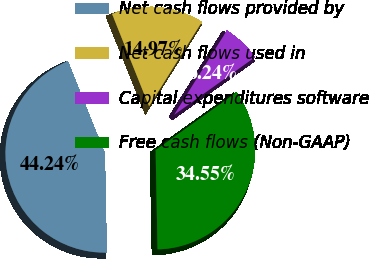Convert chart to OTSL. <chart><loc_0><loc_0><loc_500><loc_500><pie_chart><fcel>Net cash flows provided by<fcel>Net cash flows used in<fcel>Capital expenditures software<fcel>Free cash flows (Non-GAAP)<nl><fcel>44.24%<fcel>14.97%<fcel>6.24%<fcel>34.55%<nl></chart> 